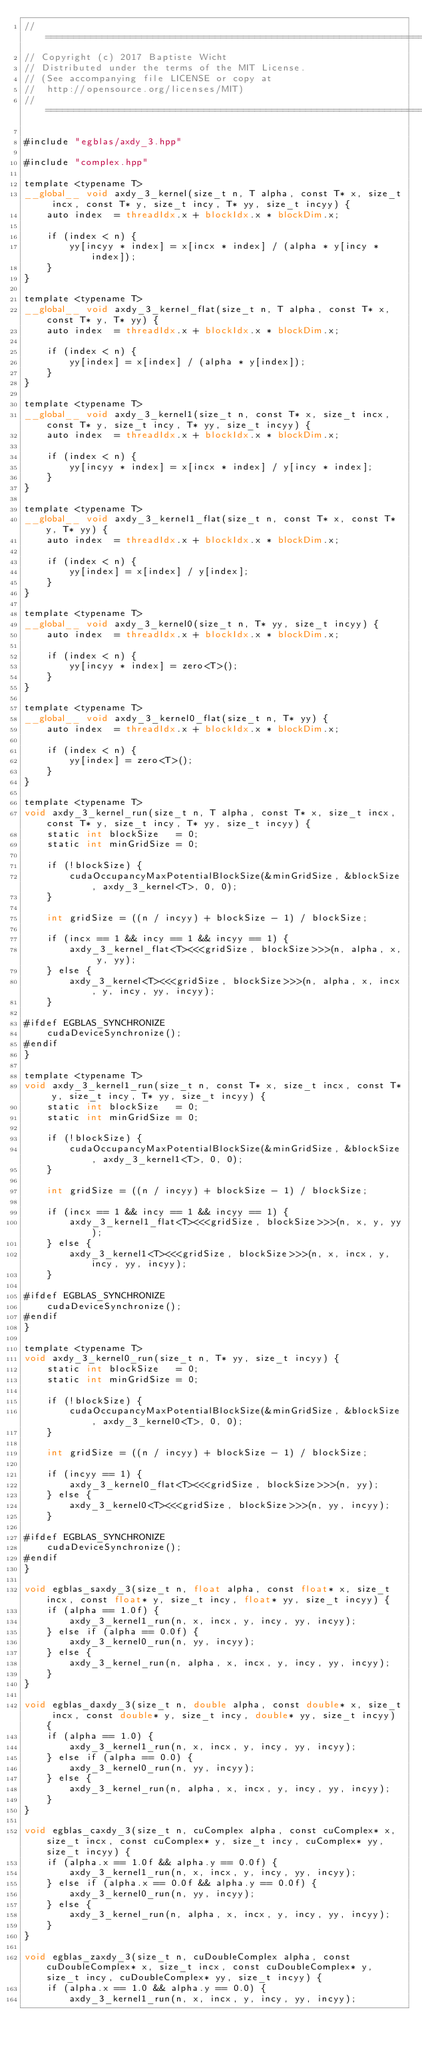<code> <loc_0><loc_0><loc_500><loc_500><_Cuda_>//=======================================================================
// Copyright (c) 2017 Baptiste Wicht
// Distributed under the terms of the MIT License.
// (See accompanying file LICENSE or copy at
//  http://opensource.org/licenses/MIT)
//=======================================================================

#include "egblas/axdy_3.hpp"

#include "complex.hpp"

template <typename T>
__global__ void axdy_3_kernel(size_t n, T alpha, const T* x, size_t incx, const T* y, size_t incy, T* yy, size_t incyy) {
    auto index  = threadIdx.x + blockIdx.x * blockDim.x;

    if (index < n) {
        yy[incyy * index] = x[incx * index] / (alpha * y[incy * index]);
    }
}

template <typename T>
__global__ void axdy_3_kernel_flat(size_t n, T alpha, const T* x, const T* y, T* yy) {
    auto index  = threadIdx.x + blockIdx.x * blockDim.x;

    if (index < n) {
        yy[index] = x[index] / (alpha * y[index]);
    }
}

template <typename T>
__global__ void axdy_3_kernel1(size_t n, const T* x, size_t incx, const T* y, size_t incy, T* yy, size_t incyy) {
    auto index  = threadIdx.x + blockIdx.x * blockDim.x;

    if (index < n) {
        yy[incyy * index] = x[incx * index] / y[incy * index];
    }
}

template <typename T>
__global__ void axdy_3_kernel1_flat(size_t n, const T* x, const T* y, T* yy) {
    auto index  = threadIdx.x + blockIdx.x * blockDim.x;

    if (index < n) {
        yy[index] = x[index] / y[index];
    }
}

template <typename T>
__global__ void axdy_3_kernel0(size_t n, T* yy, size_t incyy) {
    auto index  = threadIdx.x + blockIdx.x * blockDim.x;

    if (index < n) {
        yy[incyy * index] = zero<T>();
    }
}

template <typename T>
__global__ void axdy_3_kernel0_flat(size_t n, T* yy) {
    auto index  = threadIdx.x + blockIdx.x * blockDim.x;

    if (index < n) {
        yy[index] = zero<T>();
    }
}

template <typename T>
void axdy_3_kernel_run(size_t n, T alpha, const T* x, size_t incx, const T* y, size_t incy, T* yy, size_t incyy) {
    static int blockSize   = 0;
    static int minGridSize = 0;

    if (!blockSize) {
        cudaOccupancyMaxPotentialBlockSize(&minGridSize, &blockSize, axdy_3_kernel<T>, 0, 0);
    }

    int gridSize = ((n / incyy) + blockSize - 1) / blockSize;

    if (incx == 1 && incy == 1 && incyy == 1) {
        axdy_3_kernel_flat<T><<<gridSize, blockSize>>>(n, alpha, x, y, yy);
    } else {
        axdy_3_kernel<T><<<gridSize, blockSize>>>(n, alpha, x, incx, y, incy, yy, incyy);
    }

#ifdef EGBLAS_SYNCHRONIZE
    cudaDeviceSynchronize();
#endif
}

template <typename T>
void axdy_3_kernel1_run(size_t n, const T* x, size_t incx, const T* y, size_t incy, T* yy, size_t incyy) {
    static int blockSize   = 0;
    static int minGridSize = 0;

    if (!blockSize) {
        cudaOccupancyMaxPotentialBlockSize(&minGridSize, &blockSize, axdy_3_kernel1<T>, 0, 0);
    }

    int gridSize = ((n / incyy) + blockSize - 1) / blockSize;

    if (incx == 1 && incy == 1 && incyy == 1) {
        axdy_3_kernel1_flat<T><<<gridSize, blockSize>>>(n, x, y, yy);
    } else {
        axdy_3_kernel1<T><<<gridSize, blockSize>>>(n, x, incx, y, incy, yy, incyy);
    }

#ifdef EGBLAS_SYNCHRONIZE
    cudaDeviceSynchronize();
#endif
}

template <typename T>
void axdy_3_kernel0_run(size_t n, T* yy, size_t incyy) {
    static int blockSize   = 0;
    static int minGridSize = 0;

    if (!blockSize) {
        cudaOccupancyMaxPotentialBlockSize(&minGridSize, &blockSize, axdy_3_kernel0<T>, 0, 0);
    }

    int gridSize = ((n / incyy) + blockSize - 1) / blockSize;

    if (incyy == 1) {
        axdy_3_kernel0_flat<T><<<gridSize, blockSize>>>(n, yy);
    } else {
        axdy_3_kernel0<T><<<gridSize, blockSize>>>(n, yy, incyy);
    }

#ifdef EGBLAS_SYNCHRONIZE
    cudaDeviceSynchronize();
#endif
}

void egblas_saxdy_3(size_t n, float alpha, const float* x, size_t incx, const float* y, size_t incy, float* yy, size_t incyy) {
    if (alpha == 1.0f) {
        axdy_3_kernel1_run(n, x, incx, y, incy, yy, incyy);
    } else if (alpha == 0.0f) {
        axdy_3_kernel0_run(n, yy, incyy);
    } else {
        axdy_3_kernel_run(n, alpha, x, incx, y, incy, yy, incyy);
    }
}

void egblas_daxdy_3(size_t n, double alpha, const double* x, size_t incx, const double* y, size_t incy, double* yy, size_t incyy) {
    if (alpha == 1.0) {
        axdy_3_kernel1_run(n, x, incx, y, incy, yy, incyy);
    } else if (alpha == 0.0) {
        axdy_3_kernel0_run(n, yy, incyy);
    } else {
        axdy_3_kernel_run(n, alpha, x, incx, y, incy, yy, incyy);
    }
}

void egblas_caxdy_3(size_t n, cuComplex alpha, const cuComplex* x, size_t incx, const cuComplex* y, size_t incy, cuComplex* yy, size_t incyy) {
    if (alpha.x == 1.0f && alpha.y == 0.0f) {
        axdy_3_kernel1_run(n, x, incx, y, incy, yy, incyy);
    } else if (alpha.x == 0.0f && alpha.y == 0.0f) {
        axdy_3_kernel0_run(n, yy, incyy);
    } else {
        axdy_3_kernel_run(n, alpha, x, incx, y, incy, yy, incyy);
    }
}

void egblas_zaxdy_3(size_t n, cuDoubleComplex alpha, const cuDoubleComplex* x, size_t incx, const cuDoubleComplex* y, size_t incy, cuDoubleComplex* yy, size_t incyy) {
    if (alpha.x == 1.0 && alpha.y == 0.0) {
        axdy_3_kernel1_run(n, x, incx, y, incy, yy, incyy);</code> 